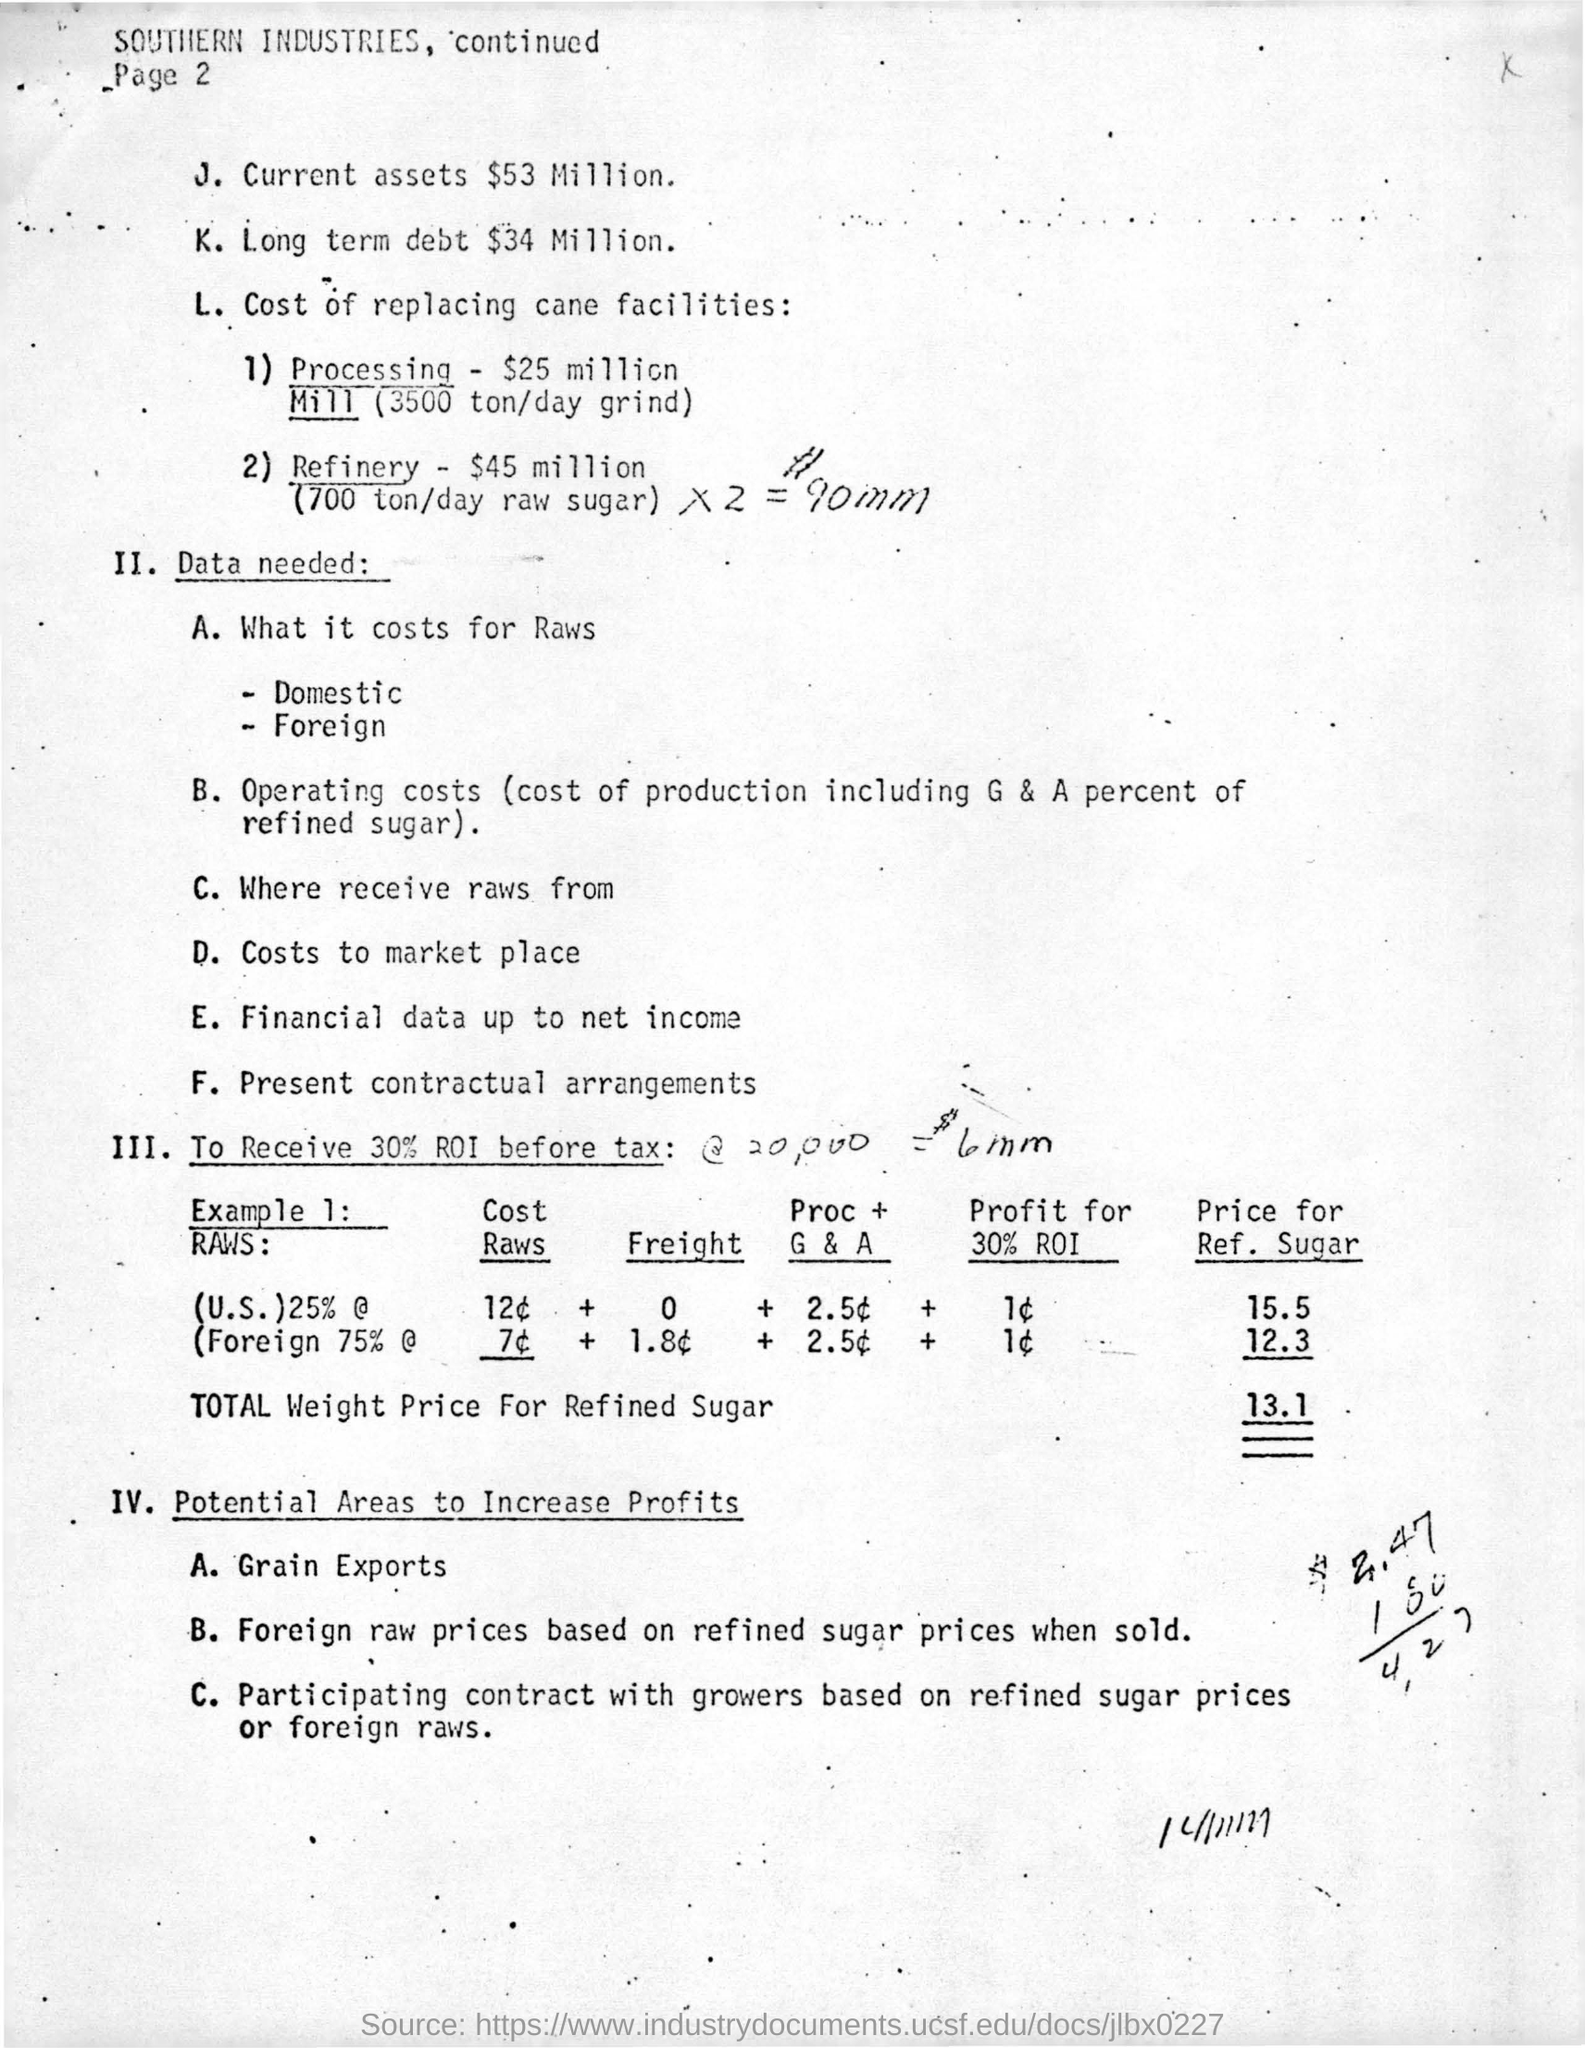List a handful of essential elements in this visual. The given industry is called "Southern Industries. The estimated cost of processing a mill with a daily capacity of 3500 tons and utilizing a grind method is approximately $25 million. The amount of long-term debt is $34 million. The long-term debt is $34 million. The total weight price for refined sugar is 13.1. 